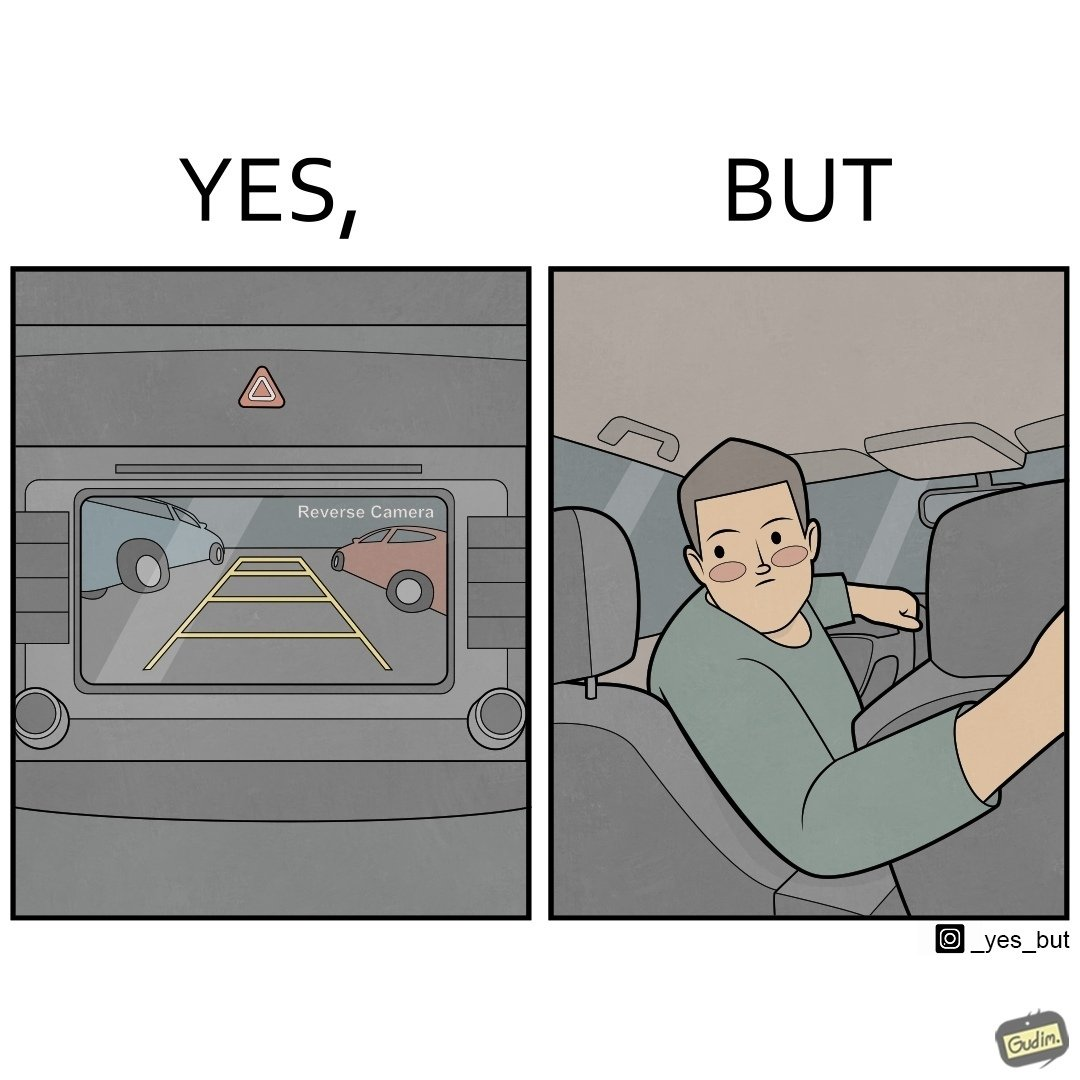Explain why this image is satirical. The images are funny since even it shows how even though modern cars are fitted with features like reverse camera, drivers still choose to not use it and reverse the old fashioned way by looking behind 